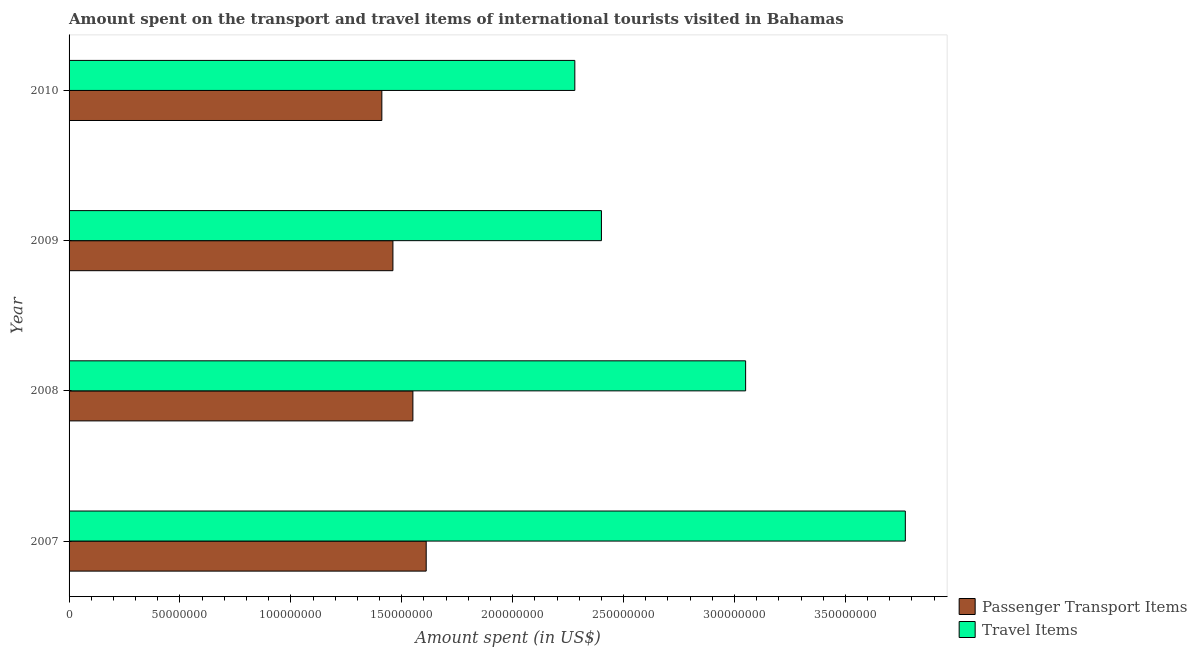How many groups of bars are there?
Offer a terse response. 4. Are the number of bars per tick equal to the number of legend labels?
Keep it short and to the point. Yes. Are the number of bars on each tick of the Y-axis equal?
Keep it short and to the point. Yes. How many bars are there on the 2nd tick from the top?
Provide a succinct answer. 2. What is the label of the 4th group of bars from the top?
Your response must be concise. 2007. What is the amount spent in travel items in 2009?
Your answer should be compact. 2.40e+08. Across all years, what is the maximum amount spent in travel items?
Give a very brief answer. 3.77e+08. Across all years, what is the minimum amount spent on passenger transport items?
Offer a terse response. 1.41e+08. What is the total amount spent in travel items in the graph?
Provide a short and direct response. 1.15e+09. What is the difference between the amount spent on passenger transport items in 2007 and that in 2008?
Offer a very short reply. 6.00e+06. What is the difference between the amount spent on passenger transport items in 2010 and the amount spent in travel items in 2007?
Offer a very short reply. -2.36e+08. What is the average amount spent in travel items per year?
Ensure brevity in your answer.  2.88e+08. In the year 2009, what is the difference between the amount spent in travel items and amount spent on passenger transport items?
Your response must be concise. 9.40e+07. What is the ratio of the amount spent in travel items in 2007 to that in 2008?
Provide a short and direct response. 1.24. Is the difference between the amount spent on passenger transport items in 2008 and 2010 greater than the difference between the amount spent in travel items in 2008 and 2010?
Your answer should be compact. No. What is the difference between the highest and the lowest amount spent in travel items?
Ensure brevity in your answer.  1.49e+08. In how many years, is the amount spent on passenger transport items greater than the average amount spent on passenger transport items taken over all years?
Your answer should be very brief. 2. What does the 2nd bar from the top in 2007 represents?
Offer a terse response. Passenger Transport Items. What does the 1st bar from the bottom in 2009 represents?
Ensure brevity in your answer.  Passenger Transport Items. How many bars are there?
Offer a very short reply. 8. How many years are there in the graph?
Your answer should be compact. 4. Does the graph contain any zero values?
Offer a terse response. No. Does the graph contain grids?
Make the answer very short. No. How many legend labels are there?
Your answer should be very brief. 2. What is the title of the graph?
Give a very brief answer. Amount spent on the transport and travel items of international tourists visited in Bahamas. Does "Register a business" appear as one of the legend labels in the graph?
Your answer should be compact. No. What is the label or title of the X-axis?
Provide a short and direct response. Amount spent (in US$). What is the Amount spent (in US$) in Passenger Transport Items in 2007?
Provide a succinct answer. 1.61e+08. What is the Amount spent (in US$) of Travel Items in 2007?
Make the answer very short. 3.77e+08. What is the Amount spent (in US$) of Passenger Transport Items in 2008?
Provide a short and direct response. 1.55e+08. What is the Amount spent (in US$) of Travel Items in 2008?
Your response must be concise. 3.05e+08. What is the Amount spent (in US$) of Passenger Transport Items in 2009?
Offer a very short reply. 1.46e+08. What is the Amount spent (in US$) of Travel Items in 2009?
Offer a terse response. 2.40e+08. What is the Amount spent (in US$) of Passenger Transport Items in 2010?
Your answer should be very brief. 1.41e+08. What is the Amount spent (in US$) of Travel Items in 2010?
Offer a very short reply. 2.28e+08. Across all years, what is the maximum Amount spent (in US$) of Passenger Transport Items?
Ensure brevity in your answer.  1.61e+08. Across all years, what is the maximum Amount spent (in US$) in Travel Items?
Provide a short and direct response. 3.77e+08. Across all years, what is the minimum Amount spent (in US$) in Passenger Transport Items?
Ensure brevity in your answer.  1.41e+08. Across all years, what is the minimum Amount spent (in US$) in Travel Items?
Ensure brevity in your answer.  2.28e+08. What is the total Amount spent (in US$) of Passenger Transport Items in the graph?
Your response must be concise. 6.03e+08. What is the total Amount spent (in US$) of Travel Items in the graph?
Provide a short and direct response. 1.15e+09. What is the difference between the Amount spent (in US$) in Passenger Transport Items in 2007 and that in 2008?
Give a very brief answer. 6.00e+06. What is the difference between the Amount spent (in US$) in Travel Items in 2007 and that in 2008?
Provide a succinct answer. 7.20e+07. What is the difference between the Amount spent (in US$) of Passenger Transport Items in 2007 and that in 2009?
Provide a short and direct response. 1.50e+07. What is the difference between the Amount spent (in US$) of Travel Items in 2007 and that in 2009?
Your answer should be compact. 1.37e+08. What is the difference between the Amount spent (in US$) of Passenger Transport Items in 2007 and that in 2010?
Offer a very short reply. 2.00e+07. What is the difference between the Amount spent (in US$) of Travel Items in 2007 and that in 2010?
Your response must be concise. 1.49e+08. What is the difference between the Amount spent (in US$) in Passenger Transport Items in 2008 and that in 2009?
Offer a very short reply. 9.00e+06. What is the difference between the Amount spent (in US$) of Travel Items in 2008 and that in 2009?
Provide a succinct answer. 6.50e+07. What is the difference between the Amount spent (in US$) of Passenger Transport Items in 2008 and that in 2010?
Offer a terse response. 1.40e+07. What is the difference between the Amount spent (in US$) in Travel Items in 2008 and that in 2010?
Keep it short and to the point. 7.70e+07. What is the difference between the Amount spent (in US$) of Passenger Transport Items in 2009 and that in 2010?
Keep it short and to the point. 5.00e+06. What is the difference between the Amount spent (in US$) of Passenger Transport Items in 2007 and the Amount spent (in US$) of Travel Items in 2008?
Your answer should be very brief. -1.44e+08. What is the difference between the Amount spent (in US$) in Passenger Transport Items in 2007 and the Amount spent (in US$) in Travel Items in 2009?
Your response must be concise. -7.90e+07. What is the difference between the Amount spent (in US$) in Passenger Transport Items in 2007 and the Amount spent (in US$) in Travel Items in 2010?
Offer a terse response. -6.70e+07. What is the difference between the Amount spent (in US$) in Passenger Transport Items in 2008 and the Amount spent (in US$) in Travel Items in 2009?
Give a very brief answer. -8.50e+07. What is the difference between the Amount spent (in US$) in Passenger Transport Items in 2008 and the Amount spent (in US$) in Travel Items in 2010?
Make the answer very short. -7.30e+07. What is the difference between the Amount spent (in US$) in Passenger Transport Items in 2009 and the Amount spent (in US$) in Travel Items in 2010?
Your answer should be very brief. -8.20e+07. What is the average Amount spent (in US$) of Passenger Transport Items per year?
Your response must be concise. 1.51e+08. What is the average Amount spent (in US$) of Travel Items per year?
Offer a very short reply. 2.88e+08. In the year 2007, what is the difference between the Amount spent (in US$) in Passenger Transport Items and Amount spent (in US$) in Travel Items?
Provide a short and direct response. -2.16e+08. In the year 2008, what is the difference between the Amount spent (in US$) of Passenger Transport Items and Amount spent (in US$) of Travel Items?
Make the answer very short. -1.50e+08. In the year 2009, what is the difference between the Amount spent (in US$) of Passenger Transport Items and Amount spent (in US$) of Travel Items?
Ensure brevity in your answer.  -9.40e+07. In the year 2010, what is the difference between the Amount spent (in US$) of Passenger Transport Items and Amount spent (in US$) of Travel Items?
Your answer should be very brief. -8.70e+07. What is the ratio of the Amount spent (in US$) of Passenger Transport Items in 2007 to that in 2008?
Your answer should be very brief. 1.04. What is the ratio of the Amount spent (in US$) of Travel Items in 2007 to that in 2008?
Make the answer very short. 1.24. What is the ratio of the Amount spent (in US$) in Passenger Transport Items in 2007 to that in 2009?
Provide a short and direct response. 1.1. What is the ratio of the Amount spent (in US$) in Travel Items in 2007 to that in 2009?
Ensure brevity in your answer.  1.57. What is the ratio of the Amount spent (in US$) in Passenger Transport Items in 2007 to that in 2010?
Offer a very short reply. 1.14. What is the ratio of the Amount spent (in US$) of Travel Items in 2007 to that in 2010?
Your answer should be compact. 1.65. What is the ratio of the Amount spent (in US$) in Passenger Transport Items in 2008 to that in 2009?
Give a very brief answer. 1.06. What is the ratio of the Amount spent (in US$) in Travel Items in 2008 to that in 2009?
Your answer should be very brief. 1.27. What is the ratio of the Amount spent (in US$) in Passenger Transport Items in 2008 to that in 2010?
Keep it short and to the point. 1.1. What is the ratio of the Amount spent (in US$) of Travel Items in 2008 to that in 2010?
Keep it short and to the point. 1.34. What is the ratio of the Amount spent (in US$) in Passenger Transport Items in 2009 to that in 2010?
Ensure brevity in your answer.  1.04. What is the ratio of the Amount spent (in US$) in Travel Items in 2009 to that in 2010?
Offer a terse response. 1.05. What is the difference between the highest and the second highest Amount spent (in US$) in Passenger Transport Items?
Offer a very short reply. 6.00e+06. What is the difference between the highest and the second highest Amount spent (in US$) in Travel Items?
Offer a terse response. 7.20e+07. What is the difference between the highest and the lowest Amount spent (in US$) of Travel Items?
Your answer should be very brief. 1.49e+08. 